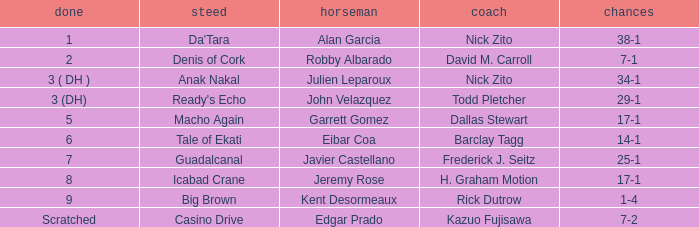What is the Finished place for da'tara trained by Nick zito? 1.0. 